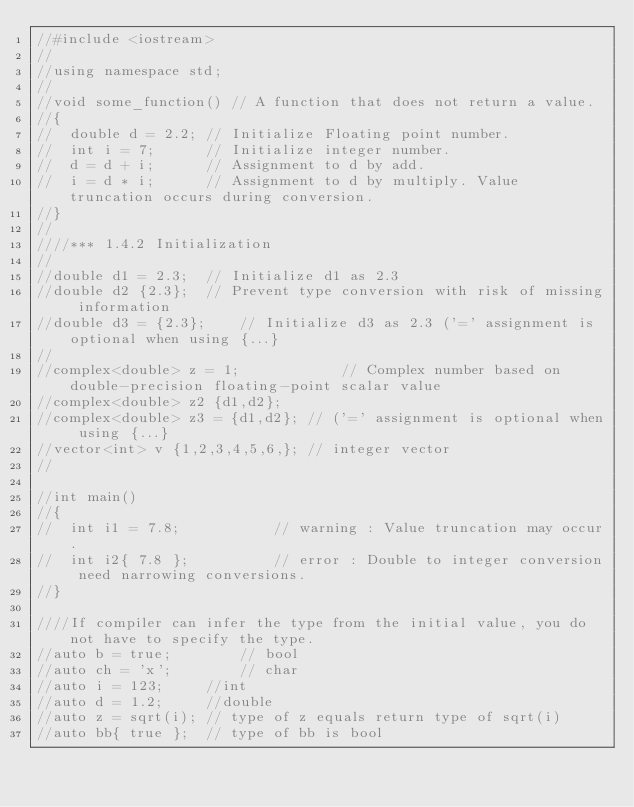Convert code to text. <code><loc_0><loc_0><loc_500><loc_500><_C++_>//#include <iostream>
//
//using namespace std;
//
//void some_function() // A function that does not return a value.
//{
//	double d = 2.2;	// Initialize Floating point number.
//	int i = 7;		// Initialize integer number.
//	d = d + i;		// Assignment to d by add.
//	i = d * i;		// Assignment to d by multiply. Value truncation occurs during conversion.
//}
//
////*** 1.4.2 Initialization
//
//double d1 = 2.3;	// Initialize d1 as 2.3
//double d2 {2.3};	// Prevent type conversion with risk of missing information
//double d3 = {2.3};	// Initialize d3 as 2.3 ('=' assignment is optional when using {...}
//
//complex<double> z = 1;			// Complex number based on double-precision floating-point scalar value
//complex<double> z2 {d1,d2};
//complex<double> z3 = {d1,d2};	// ('=' assignment is optional when using {...}
//vector<int> v {1,2,3,4,5,6,};	// integer vector
//

//int main()
//{
//	int i1 = 7.8;			// warning : Value truncation may occur.
//	int i2{ 7.8 };			// error : Double to integer conversion need narrowing conversions.
//}

////If compiler can infer the type from the initial value, you do not have to specify the type.
//auto b = true;		// bool
//auto ch = 'x';		// char
//auto i = 123;		//int
//auto d = 1.2;		//double
//auto z = sqrt(i);	// type of z equals return type of sqrt(i)
//auto bb{ true };	// type of bb is bool</code> 